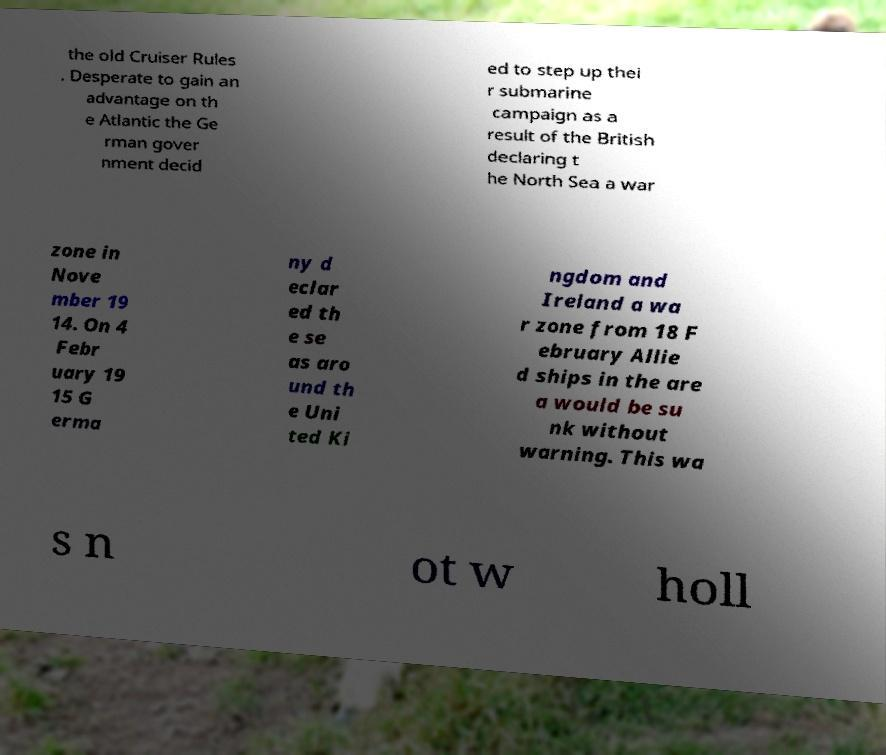Can you accurately transcribe the text from the provided image for me? the old Cruiser Rules . Desperate to gain an advantage on th e Atlantic the Ge rman gover nment decid ed to step up thei r submarine campaign as a result of the British declaring t he North Sea a war zone in Nove mber 19 14. On 4 Febr uary 19 15 G erma ny d eclar ed th e se as aro und th e Uni ted Ki ngdom and Ireland a wa r zone from 18 F ebruary Allie d ships in the are a would be su nk without warning. This wa s n ot w holl 